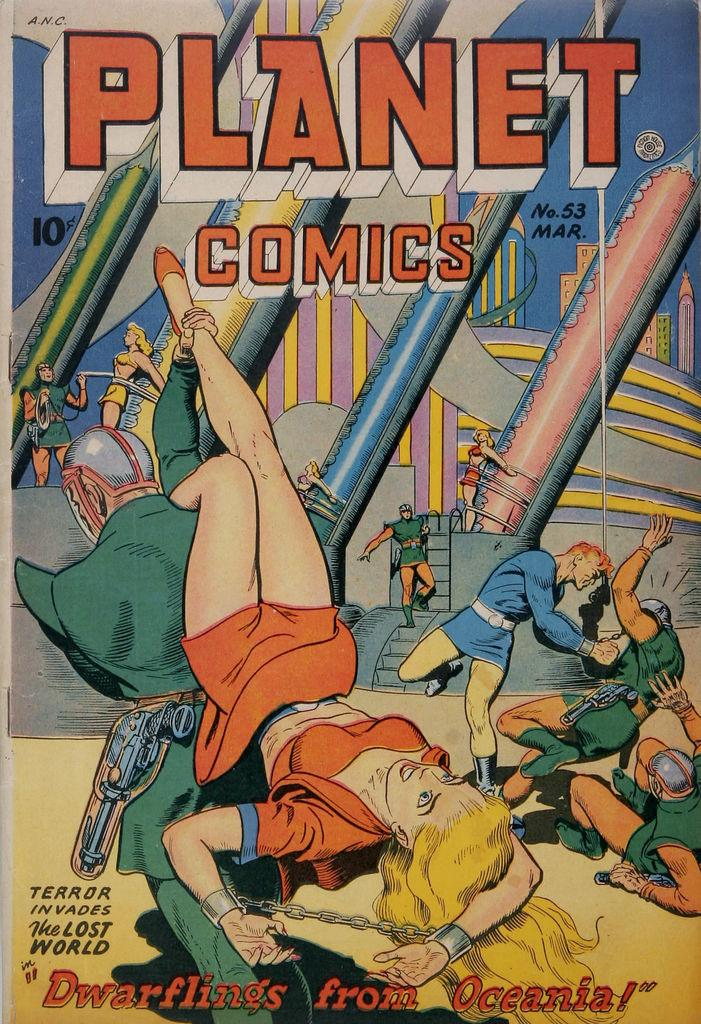<image>
Write a terse but informative summary of the picture. The Dwarflings from Ocania was a No. 53 edition of Planet Comics. 